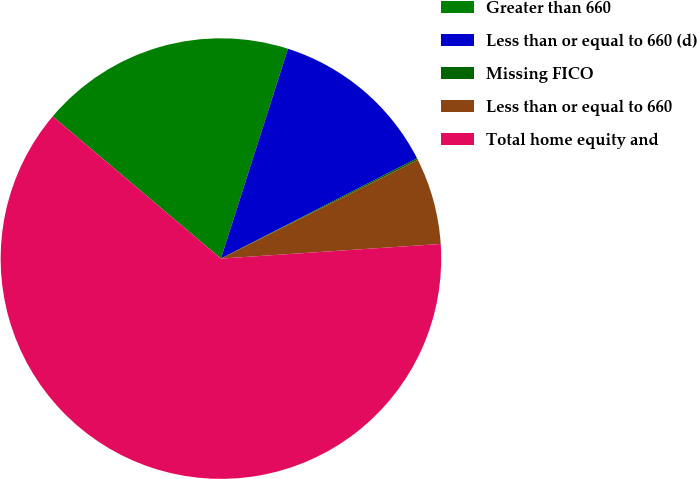Convert chart to OTSL. <chart><loc_0><loc_0><loc_500><loc_500><pie_chart><fcel>Greater than 660<fcel>Less than or equal to 660 (d)<fcel>Missing FICO<fcel>Less than or equal to 660<fcel>Total home equity and<nl><fcel>18.76%<fcel>12.55%<fcel>0.13%<fcel>6.34%<fcel>62.23%<nl></chart> 